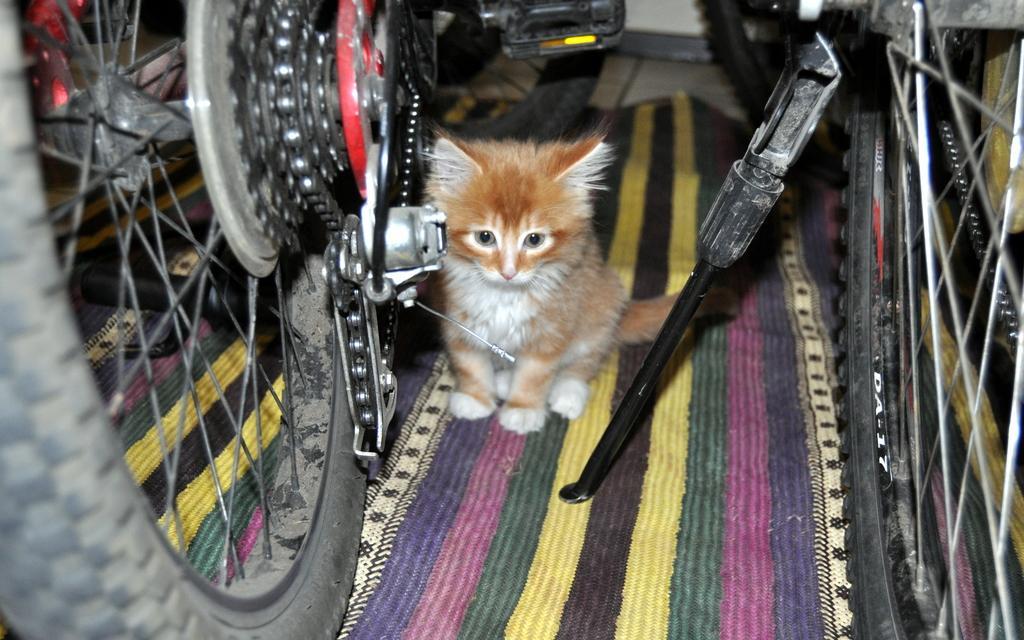How would you summarize this image in a sentence or two? In this picture I can see a cat is sitting on the mat. I can also see two bicycles. 